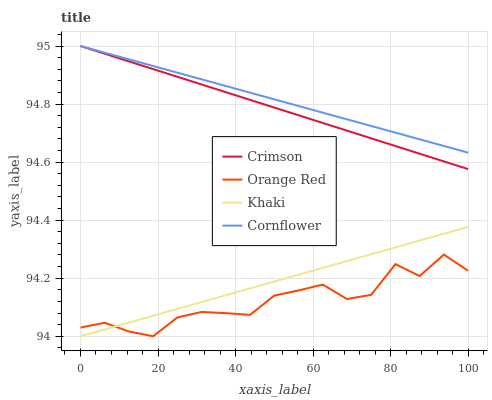Does Orange Red have the minimum area under the curve?
Answer yes or no. Yes. Does Cornflower have the maximum area under the curve?
Answer yes or no. Yes. Does Khaki have the minimum area under the curve?
Answer yes or no. No. Does Khaki have the maximum area under the curve?
Answer yes or no. No. Is Khaki the smoothest?
Answer yes or no. Yes. Is Orange Red the roughest?
Answer yes or no. Yes. Is Cornflower the smoothest?
Answer yes or no. No. Is Cornflower the roughest?
Answer yes or no. No. Does Khaki have the lowest value?
Answer yes or no. Yes. Does Cornflower have the lowest value?
Answer yes or no. No. Does Cornflower have the highest value?
Answer yes or no. Yes. Does Khaki have the highest value?
Answer yes or no. No. Is Orange Red less than Crimson?
Answer yes or no. Yes. Is Cornflower greater than Orange Red?
Answer yes or no. Yes. Does Crimson intersect Cornflower?
Answer yes or no. Yes. Is Crimson less than Cornflower?
Answer yes or no. No. Is Crimson greater than Cornflower?
Answer yes or no. No. Does Orange Red intersect Crimson?
Answer yes or no. No. 